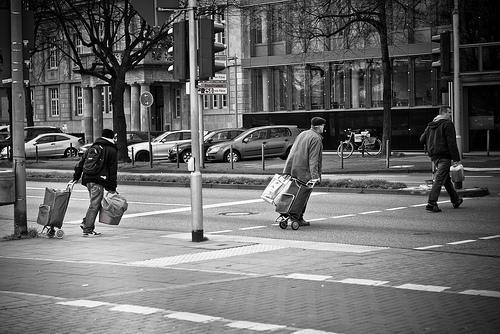How many men are there?
Give a very brief answer. 3. 